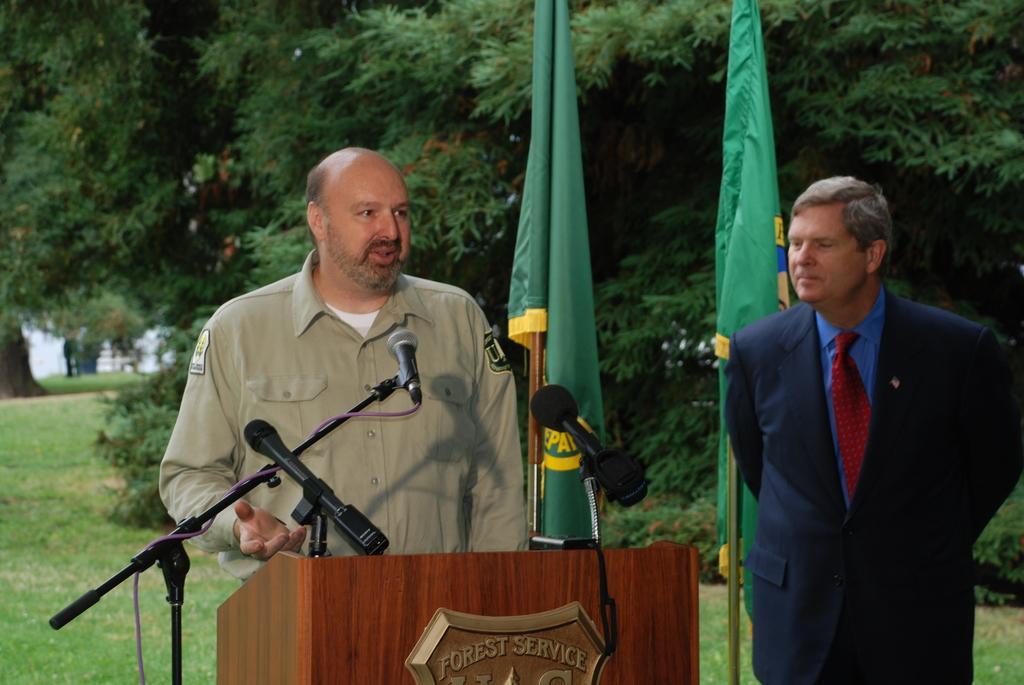Can you describe this image briefly? In this image there is a person standing, in front of him there is a table and there are mice, beside him there is another person standing, behind them there are flags and trees. 